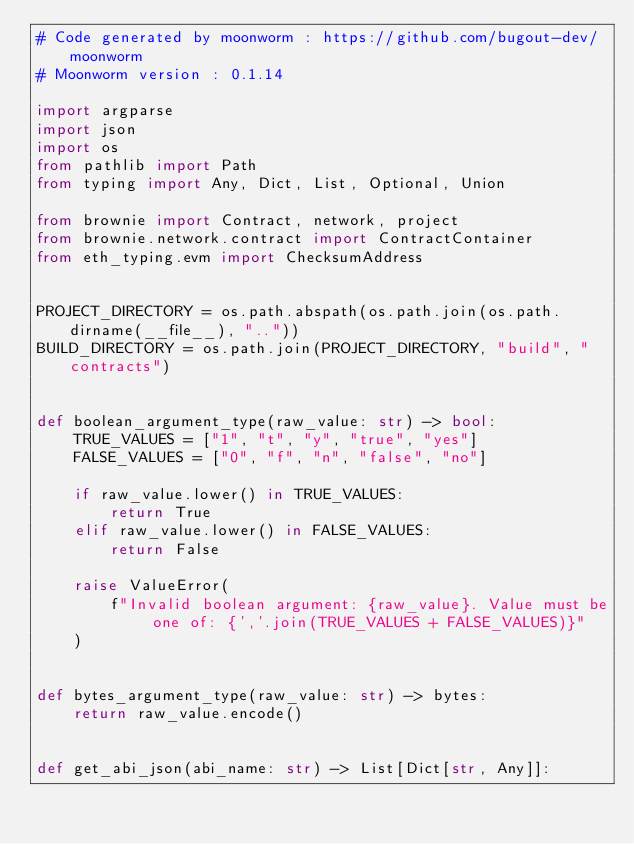Convert code to text. <code><loc_0><loc_0><loc_500><loc_500><_Python_># Code generated by moonworm : https://github.com/bugout-dev/moonworm
# Moonworm version : 0.1.14

import argparse
import json
import os
from pathlib import Path
from typing import Any, Dict, List, Optional, Union

from brownie import Contract, network, project
from brownie.network.contract import ContractContainer
from eth_typing.evm import ChecksumAddress


PROJECT_DIRECTORY = os.path.abspath(os.path.join(os.path.dirname(__file__), ".."))
BUILD_DIRECTORY = os.path.join(PROJECT_DIRECTORY, "build", "contracts")


def boolean_argument_type(raw_value: str) -> bool:
    TRUE_VALUES = ["1", "t", "y", "true", "yes"]
    FALSE_VALUES = ["0", "f", "n", "false", "no"]

    if raw_value.lower() in TRUE_VALUES:
        return True
    elif raw_value.lower() in FALSE_VALUES:
        return False

    raise ValueError(
        f"Invalid boolean argument: {raw_value}. Value must be one of: {','.join(TRUE_VALUES + FALSE_VALUES)}"
    )


def bytes_argument_type(raw_value: str) -> bytes:
    return raw_value.encode()


def get_abi_json(abi_name: str) -> List[Dict[str, Any]]:</code> 